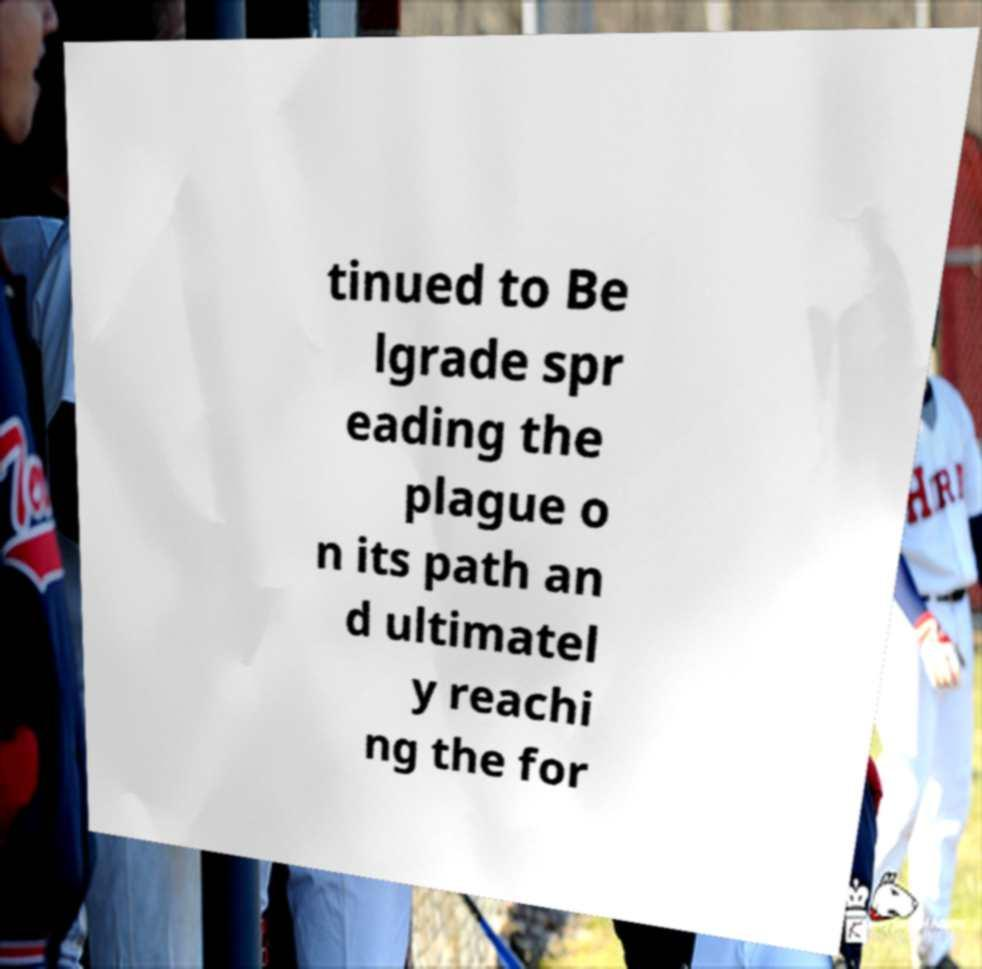Can you accurately transcribe the text from the provided image for me? tinued to Be lgrade spr eading the plague o n its path an d ultimatel y reachi ng the for 